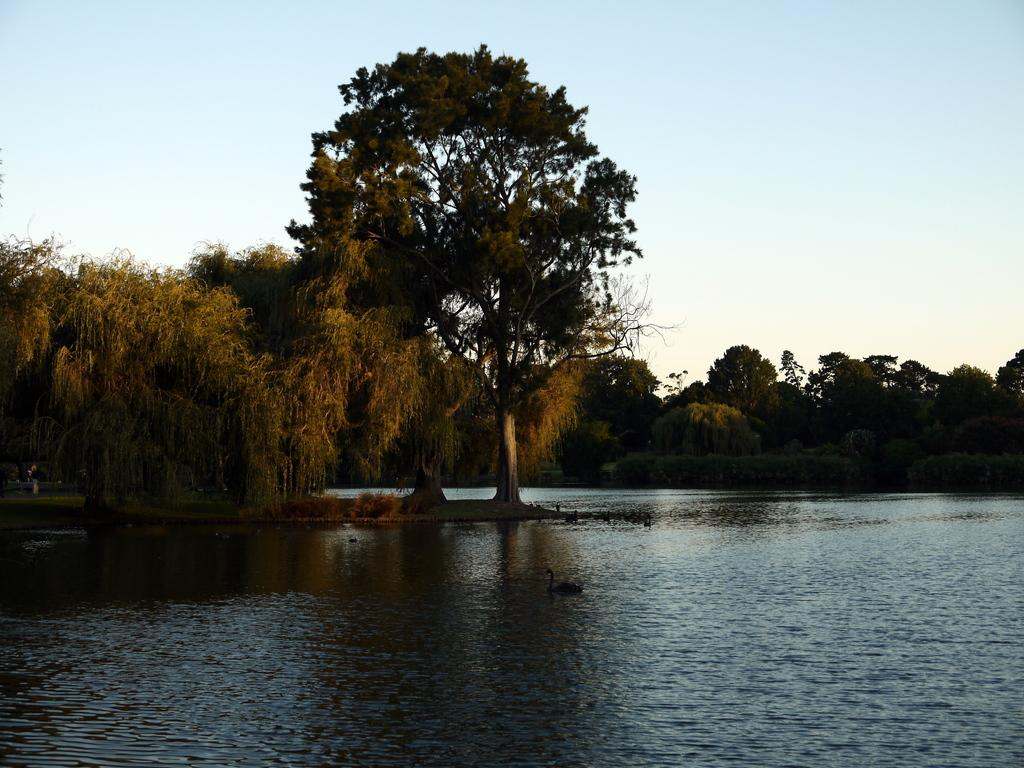What type of animals are in the image? There are ducks in the image. What are the ducks doing in the image? The ducks are swimming in the water. What can be seen in the background of the image? There are trees and the sky visible in the background of the image. What type of operation is being conducted on the ducks in the image? There is no operation being conducted on the ducks in the image; they are simply swimming in the water. What type of base is visible in the image? There is no base present in the image; it features ducks swimming in the water with trees and the sky visible in the background. 